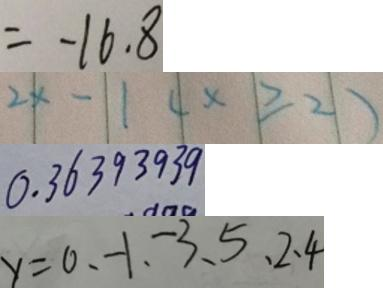Convert formula to latex. <formula><loc_0><loc_0><loc_500><loc_500>= - 1 6 . 8 
 2 x - 1 ( x \geqslant 2 ) 
 0 . 3 6 3 9 3 9 3 9 
 y = 0 , - 1 , - 3 , 5 , 2 , 4</formula> 